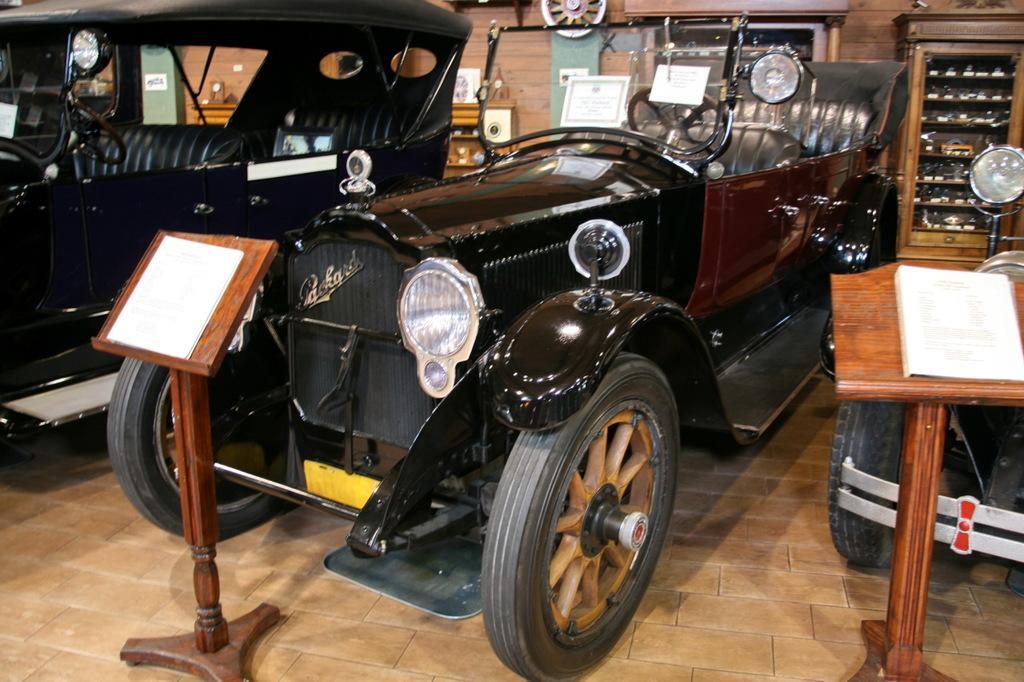Please provide a concise description of this image. This is a display of the old vintage cars. Here, there is a stand in front off the car, which explains about the car. In the background there is a wall and some cupboards. 